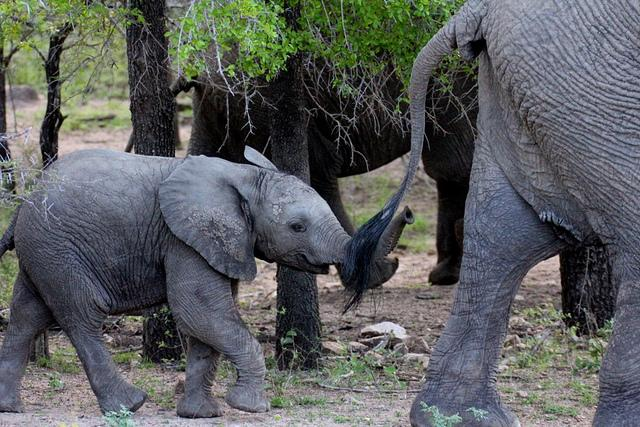Whos is the little elephant likely following?

Choices:
A) friend
B) teacher
C) mother
D) great grandfather mother 